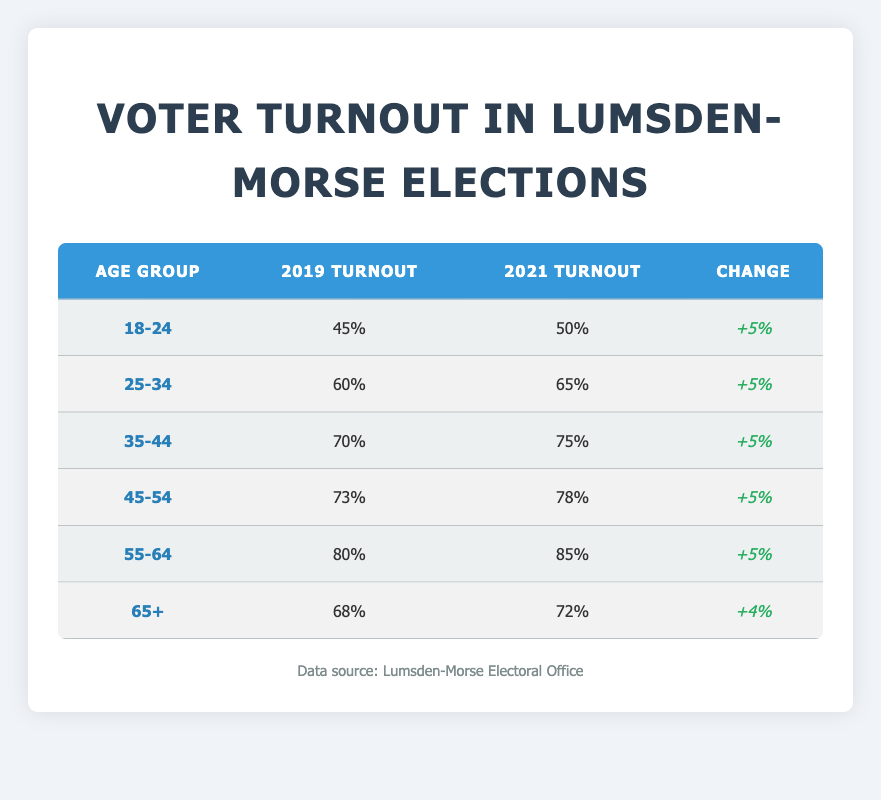What was the turnout percentage for the 45-54 age group in 2021? The table indicates that the turnout percentage for the 45-54 age group in 2021 is listed in the corresponding cell, which shows 78%.
Answer: 78% Which age group had the highest voter turnout in 2019? Looking at the data for 2019, the 55-64 age group shows the highest turnout percentage at 80%, compared to all other age groups listed.
Answer: 55-64 What is the change in voter turnout for the age group 18-24 from 2019 to 2021? The turnout percentage for this age group in 2019 was 45%, and in 2021 it rose to 50%. The change is calculated as 50% - 45% = 5%.
Answer: 5% Did the voter turnout for the 65+ age group increase from 2019 to 2021? Comparing the turnout percentages, in 2019 the turnout was 68%, and in 2021 it increased to 72%. Therefore, it did increase.
Answer: Yes What is the average voter turnout for all age groups in 2021? First, we sum the turnout percentages for 2021: 50% + 65% + 75% + 78% + 85% + 72% = 425%. Then we divide by the number of age groups (6) to get the average: 425% / 6 = approximately 70.83%.
Answer: 70.83% Which age group showed the smallest increase in turnout between 2019 and 2021? By comparing the percentage increases for each age group, we see that the 65+ age group had an increase of 4% (from 68% to 72%), while all others had an increase of 5%. Therefore, the smallest increase is for the 65+ age group.
Answer: 65+ What was the voter turnout percentage for the 55-64 age group in 2019? Referring to the table, the turnout percentage for the 55-64 age group in 2019 is indicated as 80%.
Answer: 80% If the trend continues and the voter turnout for the 25-34 age group increases by 5% again in the next election, what would be the expected turnout percentage? The current turnout percentage for 25-34 in 2021 is 65%. If it increases by another 5%, we calculate 65% + 5% = 70%.
Answer: 70% 